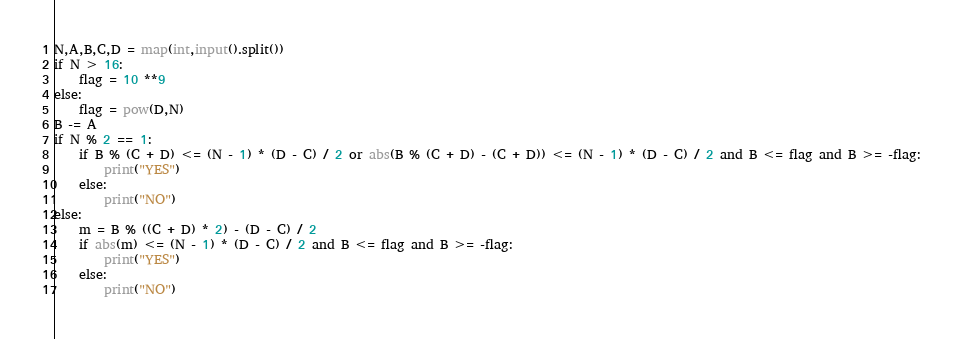<code> <loc_0><loc_0><loc_500><loc_500><_Python_>N,A,B,C,D = map(int,input().split())
if N > 16:
	flag = 10 **9
else:
	flag = pow(D,N)
B -= A
if N % 2 == 1:
	if B % (C + D) <= (N - 1) * (D - C) / 2 or abs(B % (C + D) - (C + D)) <= (N - 1) * (D - C) / 2 and B <= flag and B >= -flag:
		print("YES")
	else:
		print("NO")
else:
	m = B % ((C + D) * 2) - (D - C) / 2
	if abs(m) <= (N - 1) * (D - C) / 2 and B <= flag and B >= -flag:
		print("YES")
	else:
		print("NO")</code> 